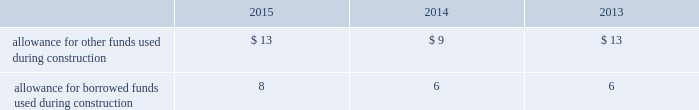The company recognizes accrued interest and penalties related to tax positions as a component of income tax expense and accounts for sales tax collected from customers and remitted to taxing authorities on a net basis .
Allowance for funds used during construction afudc is a non-cash credit to income with a corresponding charge to utility plant that represents the cost of borrowed funds or a return on equity funds devoted to plant under construction .
The regulated utility subsidiaries record afudc to the extent permitted by the pucs .
The portion of afudc attributable to borrowed funds is shown as a reduction of interest , net in the accompanying consolidated statements of operations .
Any portion of afudc attributable to equity funds would be included in other income ( expenses ) in the accompanying consolidated statements of operations .
Afudc is summarized in the table for the years ended december 31: .
Environmental costs the company 2019s water and wastewater operations are subject to u.s .
Federal , state , local and foreign requirements relating to environmental protection , and as such , the company periodically becomes subject to environmental claims in the normal course of business .
Environmental expenditures that relate to current operations or provide a future benefit are expensed or capitalized as appropriate .
Remediation costs that relate to an existing condition caused by past operations are accrued , on an undiscounted basis , when it is probable that these costs will be incurred and can be reasonably estimated .
Remediation costs accrued amounted to $ 1 and $ 2 as of december 31 , 2015 and 2014 , respectively .
The accrual relates entirely to a conservation agreement entered into by a subsidiary of the company with the national oceanic and atmospheric administration ( 201cnoaa 201d ) requiring the company to , among other provisions , implement certain measures to protect the steelhead trout and its habitat in the carmel river watershed in the state of california .
The company has agreed to pay $ 1 annually from 2010 to 2016 .
The company 2019s inception-to-date costs related to the noaa agreement were recorded in regulatory assets in the accompanying consolidated balance sheets as of december 31 , 2015 and 2014 and are expected to be fully recovered from customers in future rates .
Derivative financial instruments the company uses derivative financial instruments for purposes of hedging exposures to fluctuations in interest rates .
These derivative contracts are entered into for periods consistent with the related underlying exposures and do not constitute positions independent of those exposures .
The company does not enter into derivative contracts for speculative purposes and does not use leveraged instruments .
All derivatives are recognized on the balance sheet at fair value .
On the date the derivative contract is entered into , the company may designate the derivative as a hedge of the fair value of a recognized asset or liability ( fair-value hedge ) or a hedge of a forecasted transaction or of the variability of cash flows to be received or paid related to a recognized asset or liability ( cash-flow hedge ) .
Changes in the fair value of a fair-value hedge , along with the gain or loss on the underlying hedged item , are recorded in current-period earnings .
The effective portion of gains and losses on cash-flow hedges are recorded in other comprehensive income , until earnings are affected by the variability of cash flows .
Any ineffective portion of designated hedges is recognized in current-period earnings .
Cash flows from derivative contracts are included in net cash provided by operating activities in the accompanying consolidated statements of cash flows. .
What was the allowance for borrowed funds used during construction as a percentage of allowance for other funds used during construction during 2015? 
Computations: (8 / 13)
Answer: 0.61538. The company recognizes accrued interest and penalties related to tax positions as a component of income tax expense and accounts for sales tax collected from customers and remitted to taxing authorities on a net basis .
Allowance for funds used during construction afudc is a non-cash credit to income with a corresponding charge to utility plant that represents the cost of borrowed funds or a return on equity funds devoted to plant under construction .
The regulated utility subsidiaries record afudc to the extent permitted by the pucs .
The portion of afudc attributable to borrowed funds is shown as a reduction of interest , net in the accompanying consolidated statements of operations .
Any portion of afudc attributable to equity funds would be included in other income ( expenses ) in the accompanying consolidated statements of operations .
Afudc is summarized in the table for the years ended december 31: .
Environmental costs the company 2019s water and wastewater operations are subject to u.s .
Federal , state , local and foreign requirements relating to environmental protection , and as such , the company periodically becomes subject to environmental claims in the normal course of business .
Environmental expenditures that relate to current operations or provide a future benefit are expensed or capitalized as appropriate .
Remediation costs that relate to an existing condition caused by past operations are accrued , on an undiscounted basis , when it is probable that these costs will be incurred and can be reasonably estimated .
Remediation costs accrued amounted to $ 1 and $ 2 as of december 31 , 2015 and 2014 , respectively .
The accrual relates entirely to a conservation agreement entered into by a subsidiary of the company with the national oceanic and atmospheric administration ( 201cnoaa 201d ) requiring the company to , among other provisions , implement certain measures to protect the steelhead trout and its habitat in the carmel river watershed in the state of california .
The company has agreed to pay $ 1 annually from 2010 to 2016 .
The company 2019s inception-to-date costs related to the noaa agreement were recorded in regulatory assets in the accompanying consolidated balance sheets as of december 31 , 2015 and 2014 and are expected to be fully recovered from customers in future rates .
Derivative financial instruments the company uses derivative financial instruments for purposes of hedging exposures to fluctuations in interest rates .
These derivative contracts are entered into for periods consistent with the related underlying exposures and do not constitute positions independent of those exposures .
The company does not enter into derivative contracts for speculative purposes and does not use leveraged instruments .
All derivatives are recognized on the balance sheet at fair value .
On the date the derivative contract is entered into , the company may designate the derivative as a hedge of the fair value of a recognized asset or liability ( fair-value hedge ) or a hedge of a forecasted transaction or of the variability of cash flows to be received or paid related to a recognized asset or liability ( cash-flow hedge ) .
Changes in the fair value of a fair-value hedge , along with the gain or loss on the underlying hedged item , are recorded in current-period earnings .
The effective portion of gains and losses on cash-flow hedges are recorded in other comprehensive income , until earnings are affected by the variability of cash flows .
Any ineffective portion of designated hedges is recognized in current-period earnings .
Cash flows from derivative contracts are included in net cash provided by operating activities in the accompanying consolidated statements of cash flows. .
What was the allowance for borrowed funds used during construction as a percentage of allowance for other funds used during construction during 2014? 
Computations: (6 / 9)
Answer: 0.66667. 